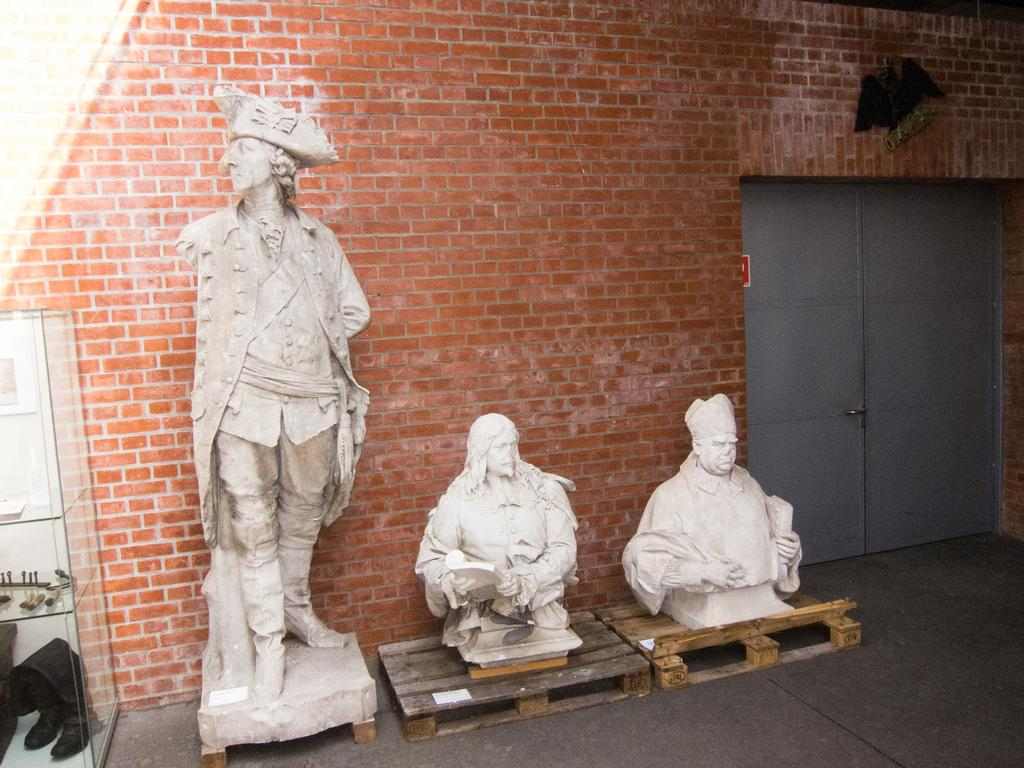What can be seen on the platforms in the image? There are statues on platforms in the image. What is visible in the background of the image? There is a brick wall and doors in the background of the image. Where is the glass cupboard located in the image? The glass cupboard is on the left side of the image. What items can be found inside the glass cupboard? There are shoes and other items inside the glass cupboard. What story does the snail tell in the image? There is no snail present in the image, so there is no story being told. How much profit can be made from the shoes inside the glass cupboard? The image does not provide any information about the value or profitability of the shoes, so it cannot be determined. 